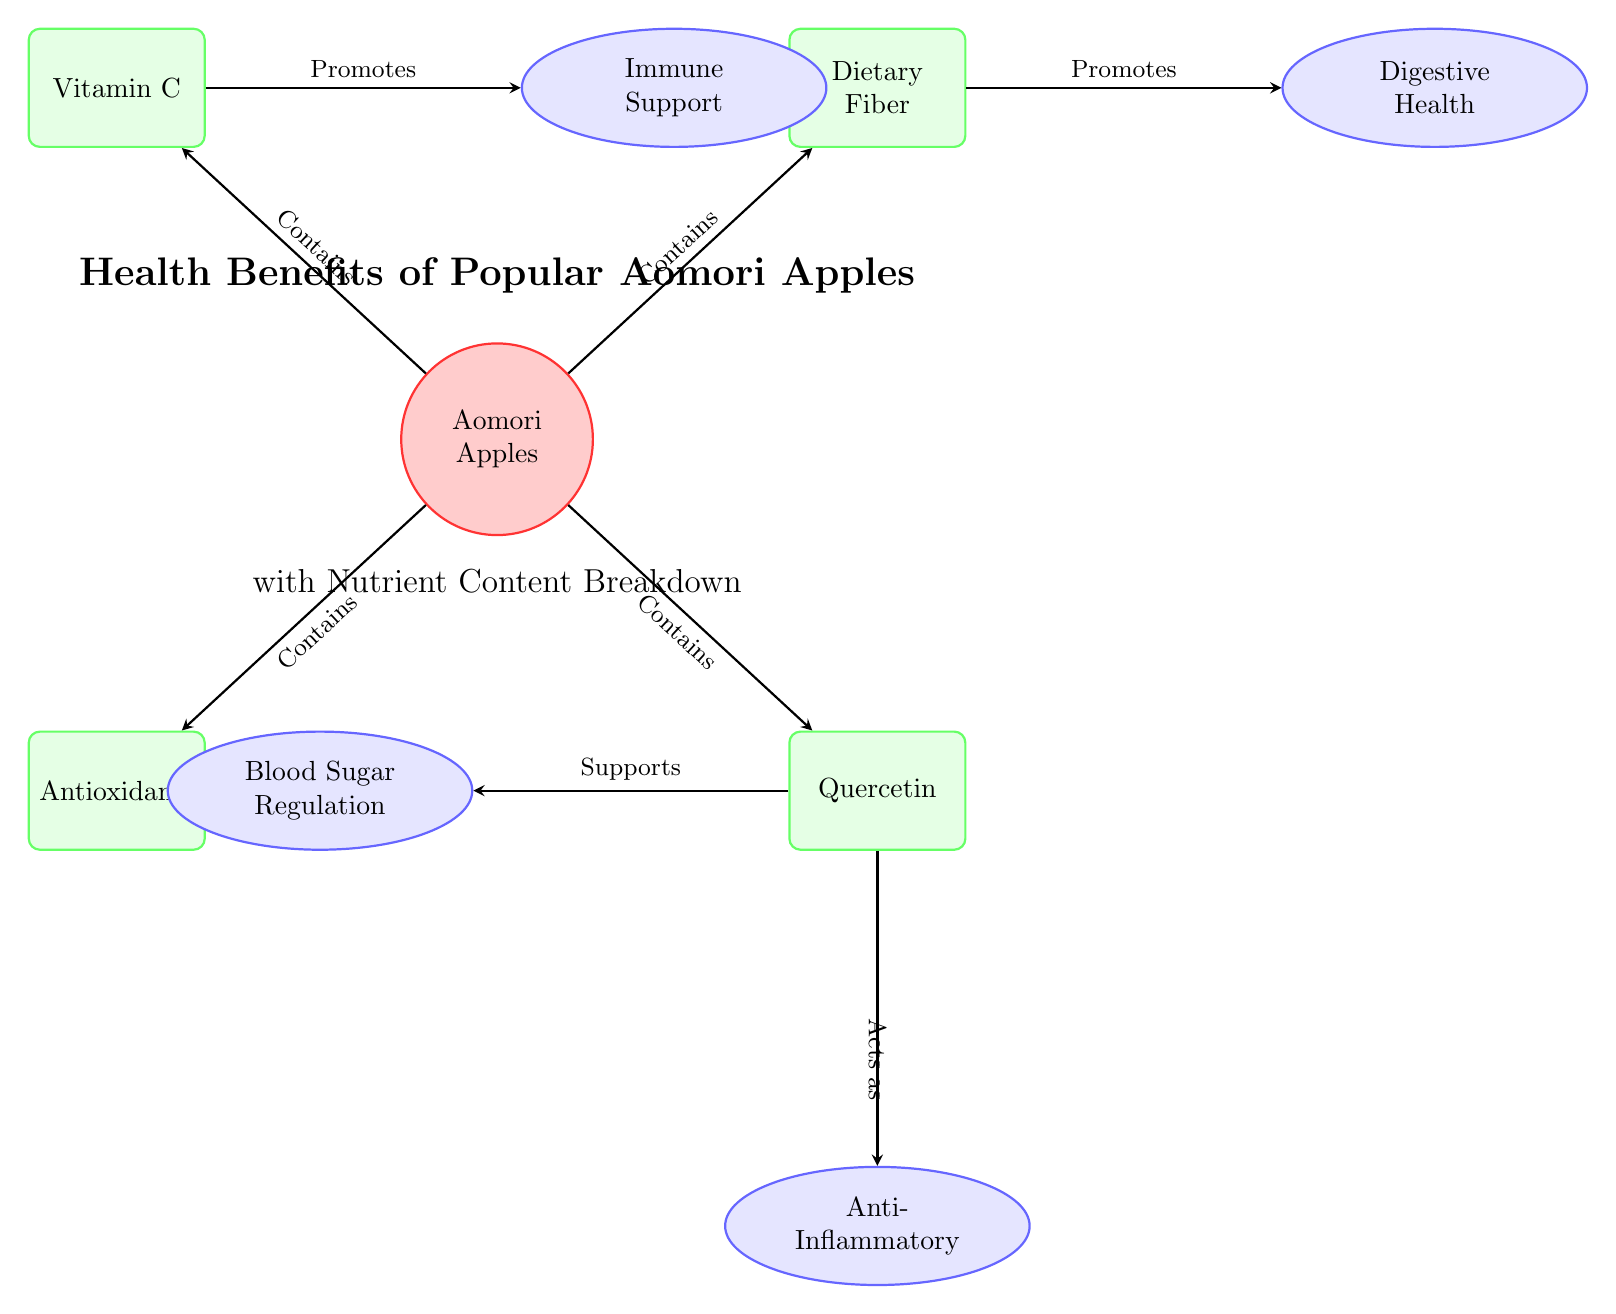What is the main subject of the diagram? The main subject indicated in the diagram is "Aomori Apples," which is represented in a circular node at the center.
Answer: Aomori Apples How many nutrient types are listed in the diagram? There are four nutrient types displayed in the diagram: Vitamin C, Dietary Fiber, Antioxidants, and Quercetin. Counting these gives a total of four.
Answer: 4 Which nutrient promotes immune support? The nutrient that promotes immune support is Vitamin C, as indicated by the directional edge from Vitamin C to Immune Support.
Answer: Vitamin C What benefit is associated with Dietary Fiber? The benefit associated with Dietary Fiber is Digestive Health, as shown by the arrow leading from Dietary Fiber to Digestive Health.
Answer: Digestive Health How does Quercetin affect blood sugar? Quercetin supports blood sugar regulation, which is indicated by the directional relationship shown in the diagram from Quercetin to Blood Sugar Regulation.
Answer: Supports Which two benefits are directly influenced by Quercetin? The two benefits directly influenced by Quercetin are Blood Sugar Regulation and Anti-Inflammatory, as evidenced by the arrows leading from Quercetin to those benefits.
Answer: Blood Sugar Regulation and Anti-Inflammatory Which nutrient in Aomori Apples is known for acting against inflammation? Quercetin is known for acting against inflammation, as indicated in the diagram with a specific edge pointing from Quercetin to the Anti-Inflammatory benefit.
Answer: Quercetin What color is used for the nutrient nodes in the diagram? The nutrient nodes are colored with a green fill, as displayed by the nutrient boxes' background in the diagram.
Answer: Green How are the relationships between benefits and their associated nutrients represented? The relationships are represented by directed arrows (edges) that show the flow from nutrients to their corresponding benefits, indicating a cause-effect relationship.
Answer: Directed arrows 